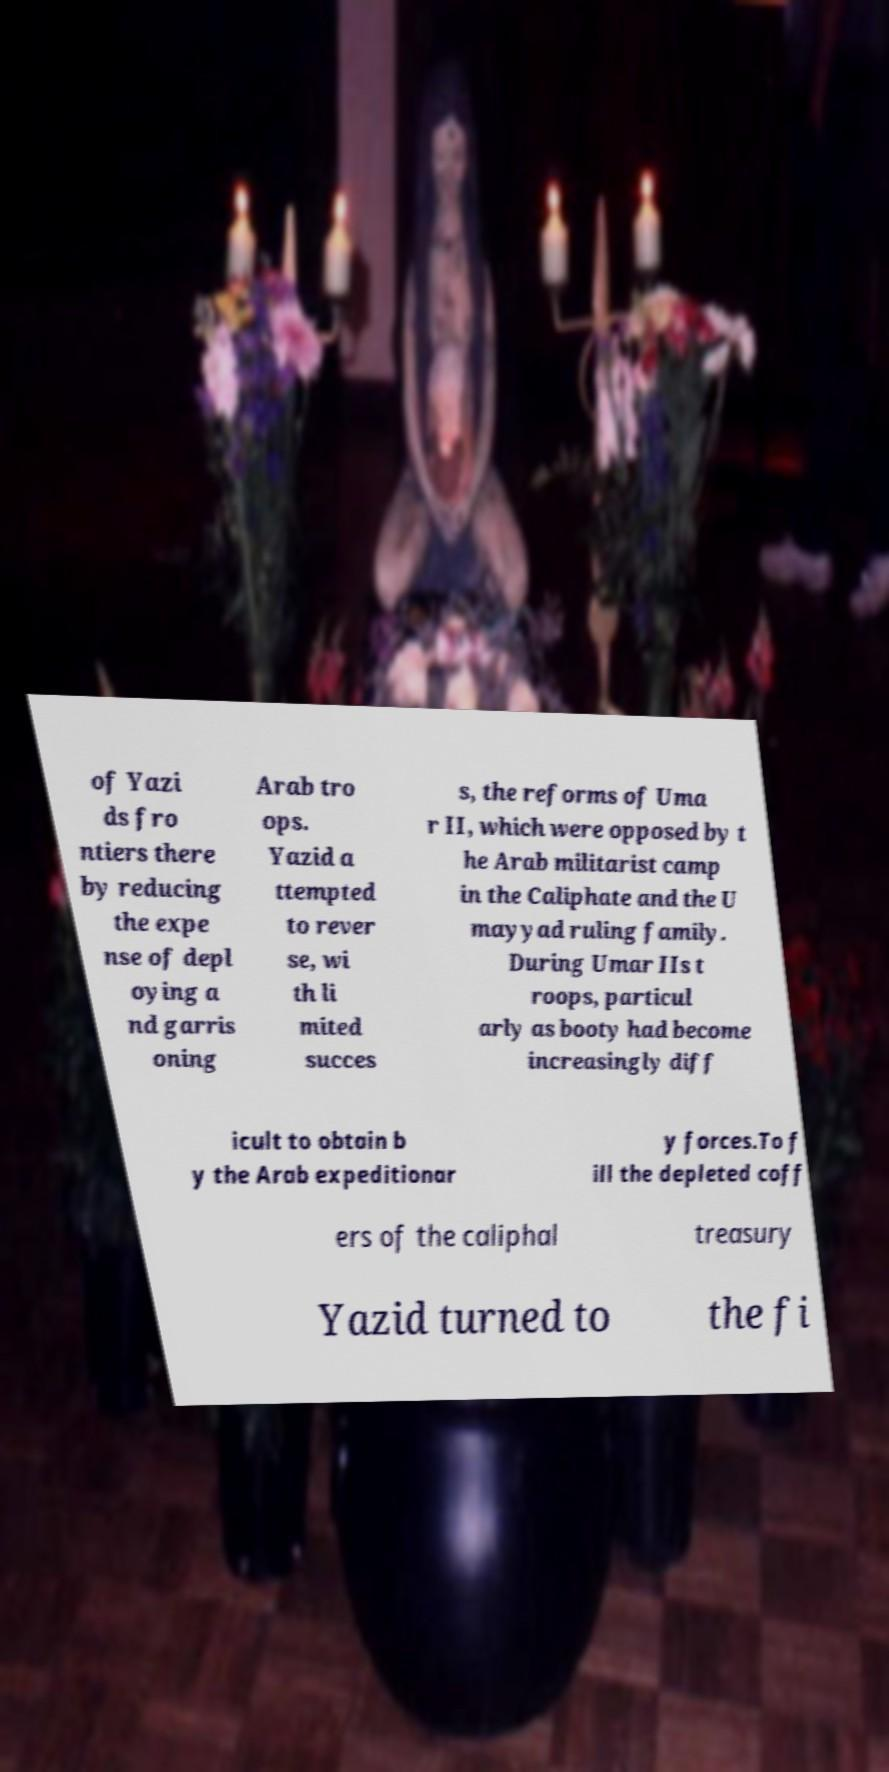Can you read and provide the text displayed in the image?This photo seems to have some interesting text. Can you extract and type it out for me? of Yazi ds fro ntiers there by reducing the expe nse of depl oying a nd garris oning Arab tro ops. Yazid a ttempted to rever se, wi th li mited succes s, the reforms of Uma r II, which were opposed by t he Arab militarist camp in the Caliphate and the U mayyad ruling family. During Umar IIs t roops, particul arly as booty had become increasingly diff icult to obtain b y the Arab expeditionar y forces.To f ill the depleted coff ers of the caliphal treasury Yazid turned to the fi 